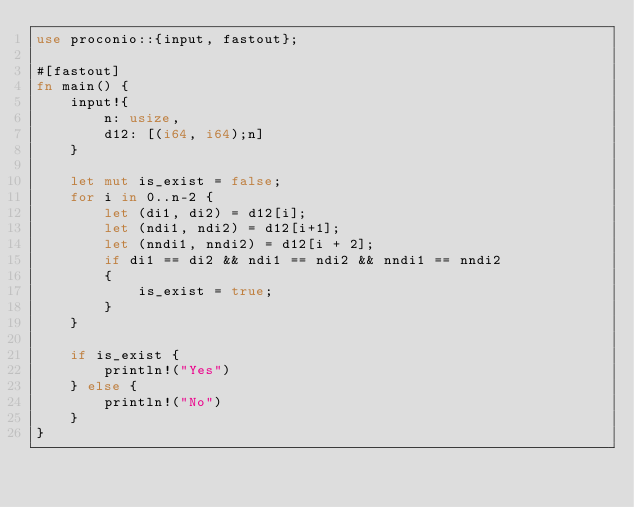<code> <loc_0><loc_0><loc_500><loc_500><_Rust_>use proconio::{input, fastout};

#[fastout]
fn main() {
    input!{
        n: usize,
        d12: [(i64, i64);n]
    }

    let mut is_exist = false;
    for i in 0..n-2 {
        let (di1, di2) = d12[i];
        let (ndi1, ndi2) = d12[i+1];
        let (nndi1, nndi2) = d12[i + 2];
        if di1 == di2 && ndi1 == ndi2 && nndi1 == nndi2
        {
            is_exist = true;
        }
    }

    if is_exist {
        println!("Yes")
    } else {
        println!("No")
    }
}
</code> 